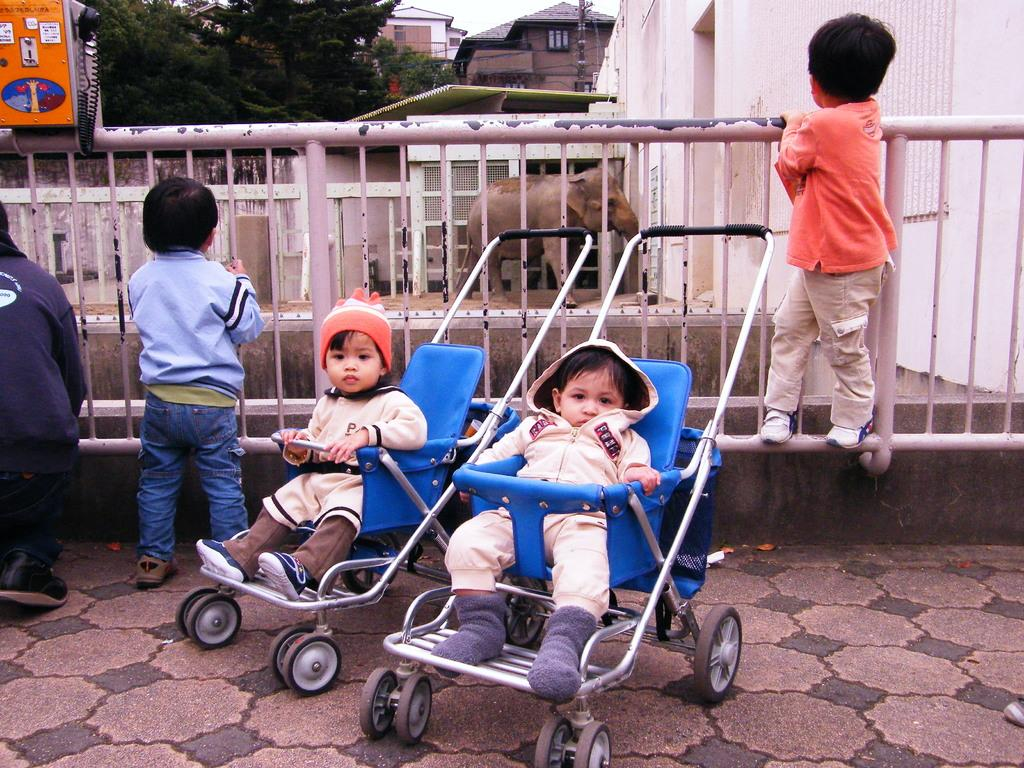What is the main subject of the image? The main subject of the image is a group of children. Where are the children located in the image? The children are on the ground. What can be seen in the background of the image? In the background of the image, there is an elephant, a fence, buildings, and trees. What type of string is being used by the children to play with the flame in the image? There is no string or flame present in the image; it features a group of children on the ground with various elements visible in the background. 